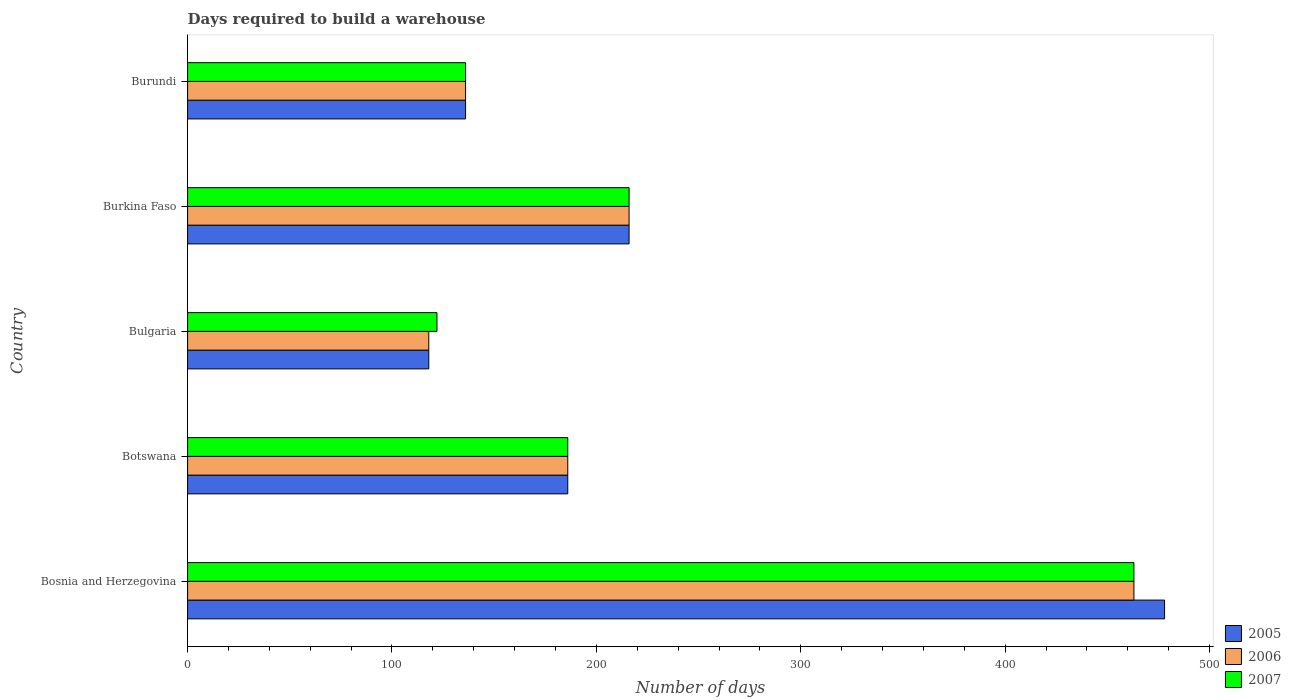How many different coloured bars are there?
Provide a succinct answer. 3. Are the number of bars on each tick of the Y-axis equal?
Provide a succinct answer. Yes. How many bars are there on the 1st tick from the top?
Make the answer very short. 3. How many bars are there on the 4th tick from the bottom?
Provide a succinct answer. 3. In how many cases, is the number of bars for a given country not equal to the number of legend labels?
Give a very brief answer. 0. What is the days required to build a warehouse in in 2007 in Bosnia and Herzegovina?
Offer a terse response. 463. Across all countries, what is the maximum days required to build a warehouse in in 2005?
Your response must be concise. 478. Across all countries, what is the minimum days required to build a warehouse in in 2007?
Offer a very short reply. 122. In which country was the days required to build a warehouse in in 2007 maximum?
Make the answer very short. Bosnia and Herzegovina. What is the total days required to build a warehouse in in 2005 in the graph?
Your answer should be very brief. 1134. What is the difference between the days required to build a warehouse in in 2006 in Bosnia and Herzegovina and that in Bulgaria?
Make the answer very short. 345. What is the average days required to build a warehouse in in 2005 per country?
Ensure brevity in your answer.  226.8. What is the difference between the days required to build a warehouse in in 2006 and days required to build a warehouse in in 2007 in Burundi?
Provide a succinct answer. 0. What is the ratio of the days required to build a warehouse in in 2006 in Botswana to that in Burkina Faso?
Make the answer very short. 0.86. Is the days required to build a warehouse in in 2006 in Bulgaria less than that in Burundi?
Your response must be concise. Yes. What is the difference between the highest and the second highest days required to build a warehouse in in 2007?
Offer a very short reply. 247. What is the difference between the highest and the lowest days required to build a warehouse in in 2005?
Offer a terse response. 360. Is the sum of the days required to build a warehouse in in 2007 in Burkina Faso and Burundi greater than the maximum days required to build a warehouse in in 2005 across all countries?
Provide a short and direct response. No. What does the 2nd bar from the bottom in Botswana represents?
Your response must be concise. 2006. Is it the case that in every country, the sum of the days required to build a warehouse in in 2005 and days required to build a warehouse in in 2007 is greater than the days required to build a warehouse in in 2006?
Provide a short and direct response. Yes. How many countries are there in the graph?
Provide a succinct answer. 5. What is the difference between two consecutive major ticks on the X-axis?
Your answer should be compact. 100. Are the values on the major ticks of X-axis written in scientific E-notation?
Your response must be concise. No. Does the graph contain any zero values?
Keep it short and to the point. No. How many legend labels are there?
Your answer should be very brief. 3. What is the title of the graph?
Provide a short and direct response. Days required to build a warehouse. What is the label or title of the X-axis?
Provide a succinct answer. Number of days. What is the Number of days in 2005 in Bosnia and Herzegovina?
Offer a very short reply. 478. What is the Number of days in 2006 in Bosnia and Herzegovina?
Offer a very short reply. 463. What is the Number of days in 2007 in Bosnia and Herzegovina?
Ensure brevity in your answer.  463. What is the Number of days in 2005 in Botswana?
Offer a very short reply. 186. What is the Number of days of 2006 in Botswana?
Give a very brief answer. 186. What is the Number of days of 2007 in Botswana?
Offer a very short reply. 186. What is the Number of days in 2005 in Bulgaria?
Your response must be concise. 118. What is the Number of days in 2006 in Bulgaria?
Keep it short and to the point. 118. What is the Number of days of 2007 in Bulgaria?
Offer a terse response. 122. What is the Number of days of 2005 in Burkina Faso?
Offer a very short reply. 216. What is the Number of days of 2006 in Burkina Faso?
Provide a succinct answer. 216. What is the Number of days in 2007 in Burkina Faso?
Make the answer very short. 216. What is the Number of days of 2005 in Burundi?
Your answer should be compact. 136. What is the Number of days in 2006 in Burundi?
Give a very brief answer. 136. What is the Number of days in 2007 in Burundi?
Give a very brief answer. 136. Across all countries, what is the maximum Number of days in 2005?
Give a very brief answer. 478. Across all countries, what is the maximum Number of days in 2006?
Your answer should be compact. 463. Across all countries, what is the maximum Number of days of 2007?
Keep it short and to the point. 463. Across all countries, what is the minimum Number of days of 2005?
Offer a very short reply. 118. Across all countries, what is the minimum Number of days of 2006?
Offer a terse response. 118. Across all countries, what is the minimum Number of days of 2007?
Make the answer very short. 122. What is the total Number of days in 2005 in the graph?
Keep it short and to the point. 1134. What is the total Number of days of 2006 in the graph?
Your answer should be compact. 1119. What is the total Number of days in 2007 in the graph?
Provide a short and direct response. 1123. What is the difference between the Number of days in 2005 in Bosnia and Herzegovina and that in Botswana?
Ensure brevity in your answer.  292. What is the difference between the Number of days in 2006 in Bosnia and Herzegovina and that in Botswana?
Give a very brief answer. 277. What is the difference between the Number of days of 2007 in Bosnia and Herzegovina and that in Botswana?
Your answer should be compact. 277. What is the difference between the Number of days of 2005 in Bosnia and Herzegovina and that in Bulgaria?
Offer a terse response. 360. What is the difference between the Number of days in 2006 in Bosnia and Herzegovina and that in Bulgaria?
Give a very brief answer. 345. What is the difference between the Number of days in 2007 in Bosnia and Herzegovina and that in Bulgaria?
Ensure brevity in your answer.  341. What is the difference between the Number of days in 2005 in Bosnia and Herzegovina and that in Burkina Faso?
Offer a terse response. 262. What is the difference between the Number of days in 2006 in Bosnia and Herzegovina and that in Burkina Faso?
Ensure brevity in your answer.  247. What is the difference between the Number of days in 2007 in Bosnia and Herzegovina and that in Burkina Faso?
Your answer should be very brief. 247. What is the difference between the Number of days of 2005 in Bosnia and Herzegovina and that in Burundi?
Offer a very short reply. 342. What is the difference between the Number of days in 2006 in Bosnia and Herzegovina and that in Burundi?
Your answer should be compact. 327. What is the difference between the Number of days of 2007 in Bosnia and Herzegovina and that in Burundi?
Your response must be concise. 327. What is the difference between the Number of days in 2005 in Botswana and that in Bulgaria?
Your answer should be compact. 68. What is the difference between the Number of days in 2006 in Botswana and that in Bulgaria?
Make the answer very short. 68. What is the difference between the Number of days of 2007 in Botswana and that in Burkina Faso?
Your answer should be compact. -30. What is the difference between the Number of days in 2005 in Botswana and that in Burundi?
Give a very brief answer. 50. What is the difference between the Number of days of 2007 in Botswana and that in Burundi?
Offer a terse response. 50. What is the difference between the Number of days of 2005 in Bulgaria and that in Burkina Faso?
Make the answer very short. -98. What is the difference between the Number of days in 2006 in Bulgaria and that in Burkina Faso?
Provide a short and direct response. -98. What is the difference between the Number of days in 2007 in Bulgaria and that in Burkina Faso?
Make the answer very short. -94. What is the difference between the Number of days of 2005 in Bulgaria and that in Burundi?
Your answer should be very brief. -18. What is the difference between the Number of days in 2007 in Bulgaria and that in Burundi?
Your answer should be very brief. -14. What is the difference between the Number of days in 2007 in Burkina Faso and that in Burundi?
Offer a terse response. 80. What is the difference between the Number of days of 2005 in Bosnia and Herzegovina and the Number of days of 2006 in Botswana?
Offer a terse response. 292. What is the difference between the Number of days of 2005 in Bosnia and Herzegovina and the Number of days of 2007 in Botswana?
Make the answer very short. 292. What is the difference between the Number of days of 2006 in Bosnia and Herzegovina and the Number of days of 2007 in Botswana?
Ensure brevity in your answer.  277. What is the difference between the Number of days in 2005 in Bosnia and Herzegovina and the Number of days in 2006 in Bulgaria?
Provide a succinct answer. 360. What is the difference between the Number of days in 2005 in Bosnia and Herzegovina and the Number of days in 2007 in Bulgaria?
Make the answer very short. 356. What is the difference between the Number of days of 2006 in Bosnia and Herzegovina and the Number of days of 2007 in Bulgaria?
Offer a terse response. 341. What is the difference between the Number of days in 2005 in Bosnia and Herzegovina and the Number of days in 2006 in Burkina Faso?
Give a very brief answer. 262. What is the difference between the Number of days of 2005 in Bosnia and Herzegovina and the Number of days of 2007 in Burkina Faso?
Your answer should be compact. 262. What is the difference between the Number of days in 2006 in Bosnia and Herzegovina and the Number of days in 2007 in Burkina Faso?
Give a very brief answer. 247. What is the difference between the Number of days of 2005 in Bosnia and Herzegovina and the Number of days of 2006 in Burundi?
Give a very brief answer. 342. What is the difference between the Number of days in 2005 in Bosnia and Herzegovina and the Number of days in 2007 in Burundi?
Provide a short and direct response. 342. What is the difference between the Number of days in 2006 in Bosnia and Herzegovina and the Number of days in 2007 in Burundi?
Keep it short and to the point. 327. What is the difference between the Number of days in 2005 in Botswana and the Number of days in 2006 in Bulgaria?
Offer a very short reply. 68. What is the difference between the Number of days in 2005 in Botswana and the Number of days in 2007 in Bulgaria?
Your response must be concise. 64. What is the difference between the Number of days of 2005 in Botswana and the Number of days of 2006 in Burkina Faso?
Your response must be concise. -30. What is the difference between the Number of days in 2005 in Bulgaria and the Number of days in 2006 in Burkina Faso?
Provide a succinct answer. -98. What is the difference between the Number of days in 2005 in Bulgaria and the Number of days in 2007 in Burkina Faso?
Your response must be concise. -98. What is the difference between the Number of days in 2006 in Bulgaria and the Number of days in 2007 in Burkina Faso?
Keep it short and to the point. -98. What is the difference between the Number of days in 2005 in Bulgaria and the Number of days in 2006 in Burundi?
Make the answer very short. -18. What is the difference between the Number of days in 2006 in Bulgaria and the Number of days in 2007 in Burundi?
Your response must be concise. -18. What is the difference between the Number of days of 2005 in Burkina Faso and the Number of days of 2007 in Burundi?
Make the answer very short. 80. What is the difference between the Number of days of 2006 in Burkina Faso and the Number of days of 2007 in Burundi?
Offer a very short reply. 80. What is the average Number of days of 2005 per country?
Your answer should be very brief. 226.8. What is the average Number of days in 2006 per country?
Your answer should be very brief. 223.8. What is the average Number of days of 2007 per country?
Make the answer very short. 224.6. What is the difference between the Number of days in 2005 and Number of days in 2007 in Bosnia and Herzegovina?
Ensure brevity in your answer.  15. What is the difference between the Number of days of 2005 and Number of days of 2006 in Botswana?
Give a very brief answer. 0. What is the difference between the Number of days of 2005 and Number of days of 2007 in Botswana?
Your answer should be very brief. 0. What is the difference between the Number of days in 2006 and Number of days in 2007 in Botswana?
Ensure brevity in your answer.  0. What is the difference between the Number of days in 2006 and Number of days in 2007 in Bulgaria?
Ensure brevity in your answer.  -4. What is the difference between the Number of days in 2005 and Number of days in 2006 in Burkina Faso?
Ensure brevity in your answer.  0. What is the difference between the Number of days of 2005 and Number of days of 2007 in Burkina Faso?
Provide a succinct answer. 0. What is the difference between the Number of days in 2005 and Number of days in 2006 in Burundi?
Offer a terse response. 0. What is the difference between the Number of days in 2005 and Number of days in 2007 in Burundi?
Offer a very short reply. 0. What is the difference between the Number of days in 2006 and Number of days in 2007 in Burundi?
Provide a succinct answer. 0. What is the ratio of the Number of days of 2005 in Bosnia and Herzegovina to that in Botswana?
Provide a short and direct response. 2.57. What is the ratio of the Number of days in 2006 in Bosnia and Herzegovina to that in Botswana?
Offer a very short reply. 2.49. What is the ratio of the Number of days of 2007 in Bosnia and Herzegovina to that in Botswana?
Give a very brief answer. 2.49. What is the ratio of the Number of days in 2005 in Bosnia and Herzegovina to that in Bulgaria?
Keep it short and to the point. 4.05. What is the ratio of the Number of days of 2006 in Bosnia and Herzegovina to that in Bulgaria?
Provide a succinct answer. 3.92. What is the ratio of the Number of days of 2007 in Bosnia and Herzegovina to that in Bulgaria?
Keep it short and to the point. 3.8. What is the ratio of the Number of days in 2005 in Bosnia and Herzegovina to that in Burkina Faso?
Your answer should be compact. 2.21. What is the ratio of the Number of days in 2006 in Bosnia and Herzegovina to that in Burkina Faso?
Keep it short and to the point. 2.14. What is the ratio of the Number of days in 2007 in Bosnia and Herzegovina to that in Burkina Faso?
Provide a succinct answer. 2.14. What is the ratio of the Number of days of 2005 in Bosnia and Herzegovina to that in Burundi?
Offer a very short reply. 3.51. What is the ratio of the Number of days in 2006 in Bosnia and Herzegovina to that in Burundi?
Your answer should be very brief. 3.4. What is the ratio of the Number of days of 2007 in Bosnia and Herzegovina to that in Burundi?
Give a very brief answer. 3.4. What is the ratio of the Number of days of 2005 in Botswana to that in Bulgaria?
Make the answer very short. 1.58. What is the ratio of the Number of days in 2006 in Botswana to that in Bulgaria?
Keep it short and to the point. 1.58. What is the ratio of the Number of days of 2007 in Botswana to that in Bulgaria?
Offer a very short reply. 1.52. What is the ratio of the Number of days in 2005 in Botswana to that in Burkina Faso?
Make the answer very short. 0.86. What is the ratio of the Number of days of 2006 in Botswana to that in Burkina Faso?
Give a very brief answer. 0.86. What is the ratio of the Number of days of 2007 in Botswana to that in Burkina Faso?
Keep it short and to the point. 0.86. What is the ratio of the Number of days of 2005 in Botswana to that in Burundi?
Offer a terse response. 1.37. What is the ratio of the Number of days of 2006 in Botswana to that in Burundi?
Your response must be concise. 1.37. What is the ratio of the Number of days of 2007 in Botswana to that in Burundi?
Give a very brief answer. 1.37. What is the ratio of the Number of days of 2005 in Bulgaria to that in Burkina Faso?
Your answer should be very brief. 0.55. What is the ratio of the Number of days of 2006 in Bulgaria to that in Burkina Faso?
Offer a very short reply. 0.55. What is the ratio of the Number of days in 2007 in Bulgaria to that in Burkina Faso?
Keep it short and to the point. 0.56. What is the ratio of the Number of days in 2005 in Bulgaria to that in Burundi?
Ensure brevity in your answer.  0.87. What is the ratio of the Number of days of 2006 in Bulgaria to that in Burundi?
Offer a very short reply. 0.87. What is the ratio of the Number of days in 2007 in Bulgaria to that in Burundi?
Your answer should be very brief. 0.9. What is the ratio of the Number of days of 2005 in Burkina Faso to that in Burundi?
Keep it short and to the point. 1.59. What is the ratio of the Number of days of 2006 in Burkina Faso to that in Burundi?
Your answer should be very brief. 1.59. What is the ratio of the Number of days in 2007 in Burkina Faso to that in Burundi?
Provide a short and direct response. 1.59. What is the difference between the highest and the second highest Number of days in 2005?
Make the answer very short. 262. What is the difference between the highest and the second highest Number of days of 2006?
Make the answer very short. 247. What is the difference between the highest and the second highest Number of days of 2007?
Offer a terse response. 247. What is the difference between the highest and the lowest Number of days of 2005?
Offer a terse response. 360. What is the difference between the highest and the lowest Number of days in 2006?
Provide a succinct answer. 345. What is the difference between the highest and the lowest Number of days of 2007?
Give a very brief answer. 341. 